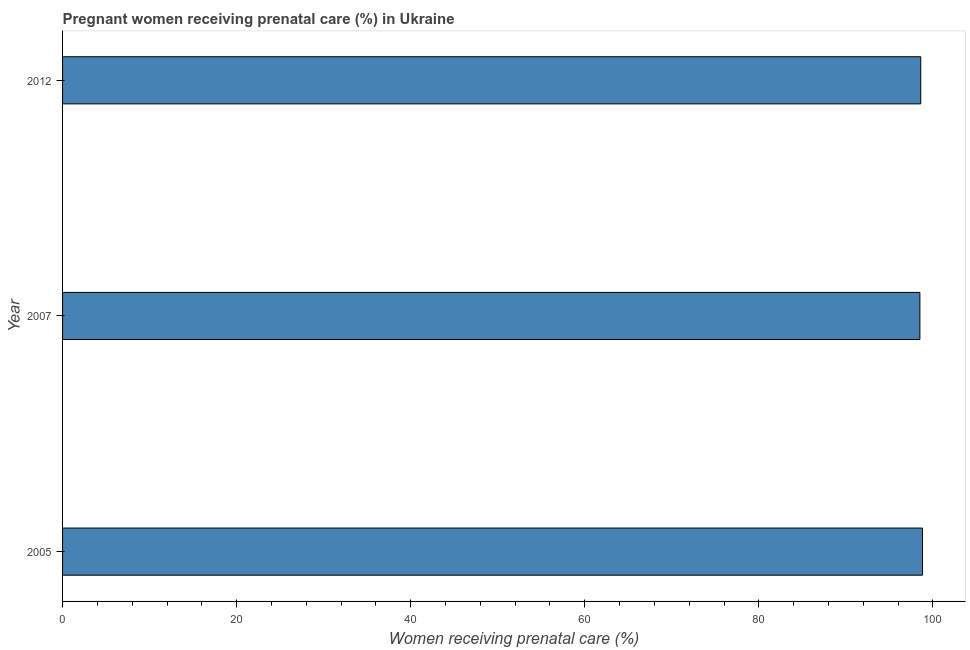Does the graph contain grids?
Provide a short and direct response. No. What is the title of the graph?
Ensure brevity in your answer.  Pregnant women receiving prenatal care (%) in Ukraine. What is the label or title of the X-axis?
Your answer should be compact. Women receiving prenatal care (%). What is the percentage of pregnant women receiving prenatal care in 2007?
Your answer should be compact. 98.5. Across all years, what is the maximum percentage of pregnant women receiving prenatal care?
Offer a terse response. 98.8. Across all years, what is the minimum percentage of pregnant women receiving prenatal care?
Make the answer very short. 98.5. What is the sum of the percentage of pregnant women receiving prenatal care?
Give a very brief answer. 295.9. What is the difference between the percentage of pregnant women receiving prenatal care in 2007 and 2012?
Offer a very short reply. -0.1. What is the average percentage of pregnant women receiving prenatal care per year?
Offer a very short reply. 98.63. What is the median percentage of pregnant women receiving prenatal care?
Make the answer very short. 98.6. What is the ratio of the percentage of pregnant women receiving prenatal care in 2007 to that in 2012?
Provide a succinct answer. 1. Is the percentage of pregnant women receiving prenatal care in 2005 less than that in 2007?
Your answer should be very brief. No. Is the difference between the percentage of pregnant women receiving prenatal care in 2005 and 2007 greater than the difference between any two years?
Offer a terse response. Yes. What is the difference between the highest and the second highest percentage of pregnant women receiving prenatal care?
Your response must be concise. 0.2. What is the difference between the highest and the lowest percentage of pregnant women receiving prenatal care?
Your answer should be compact. 0.3. In how many years, is the percentage of pregnant women receiving prenatal care greater than the average percentage of pregnant women receiving prenatal care taken over all years?
Make the answer very short. 1. What is the difference between two consecutive major ticks on the X-axis?
Your answer should be compact. 20. What is the Women receiving prenatal care (%) of 2005?
Give a very brief answer. 98.8. What is the Women receiving prenatal care (%) of 2007?
Provide a succinct answer. 98.5. What is the Women receiving prenatal care (%) in 2012?
Your answer should be very brief. 98.6. What is the difference between the Women receiving prenatal care (%) in 2005 and 2007?
Your answer should be compact. 0.3. What is the ratio of the Women receiving prenatal care (%) in 2005 to that in 2007?
Ensure brevity in your answer.  1. What is the ratio of the Women receiving prenatal care (%) in 2005 to that in 2012?
Provide a short and direct response. 1. 